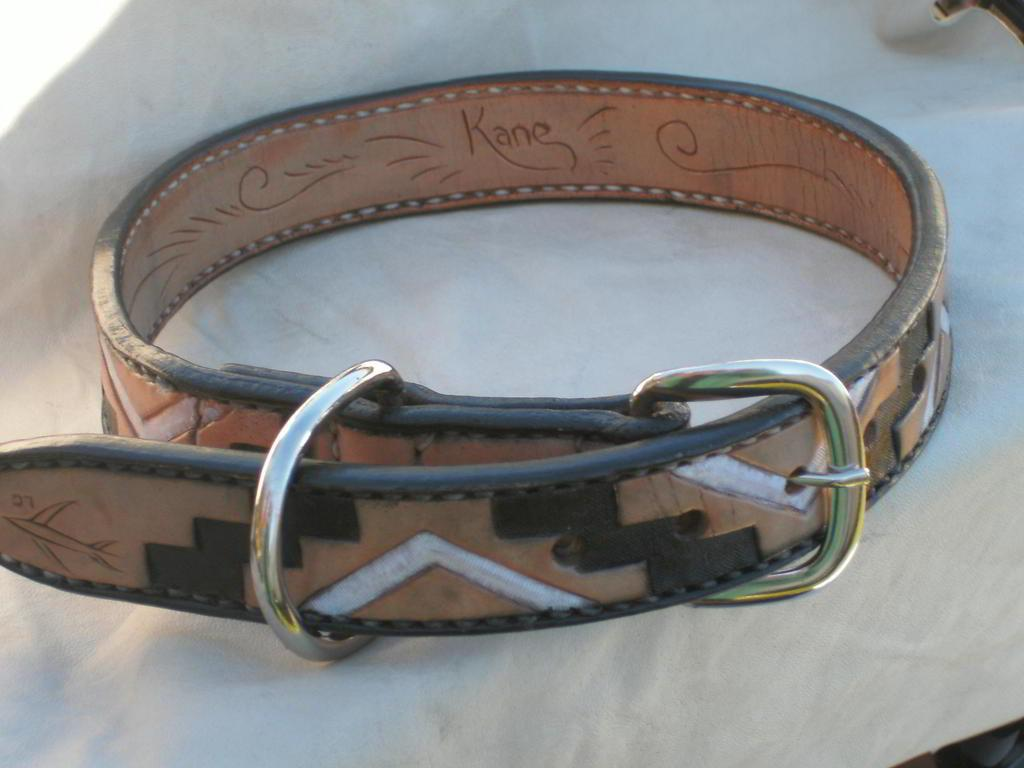What object is in the image? There is a belt in the image. Where is the belt placed? The belt is placed on a white surface. What colors can be seen on the belt? The belt has a brown and white color design. How long does the existence of the spade last in the image? There is no spade present in the image, so it cannot be determined how long its existence lasts. 